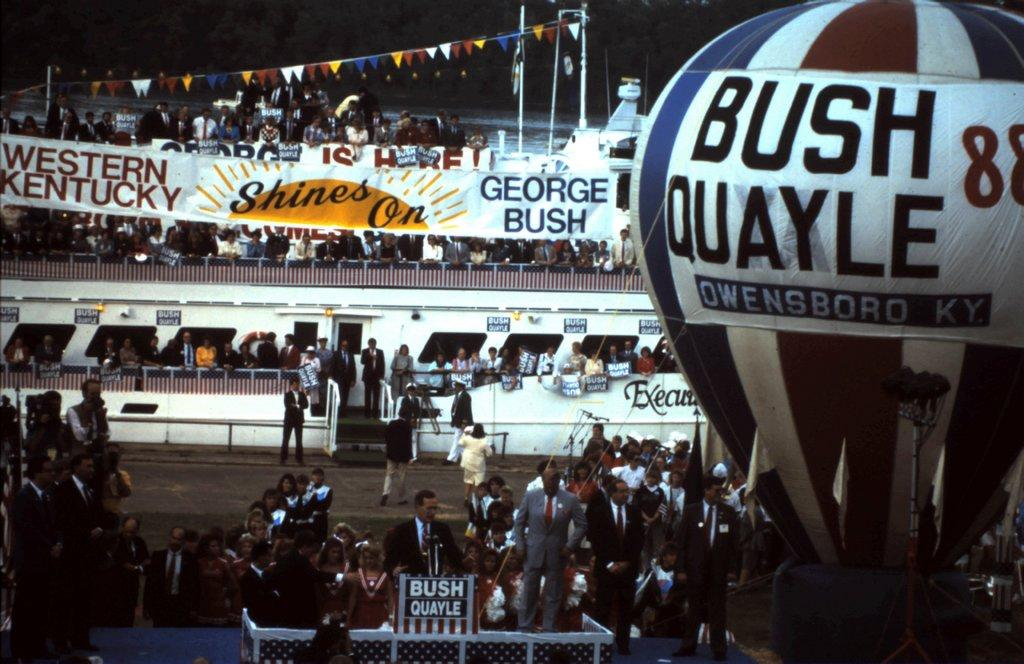What is happening in the image? There are people standing in the image. What can be seen in the background of the image? There is a ship in the background of the image. How many people are on the ship? The ship is crowded with people. What else is visible in the image? There is a parachute visible on the right side of the image. What type of canvas is being used to paint the ship in the image? There is no canvas or painting activity present in the image; it is a photograph of a ship and people. 